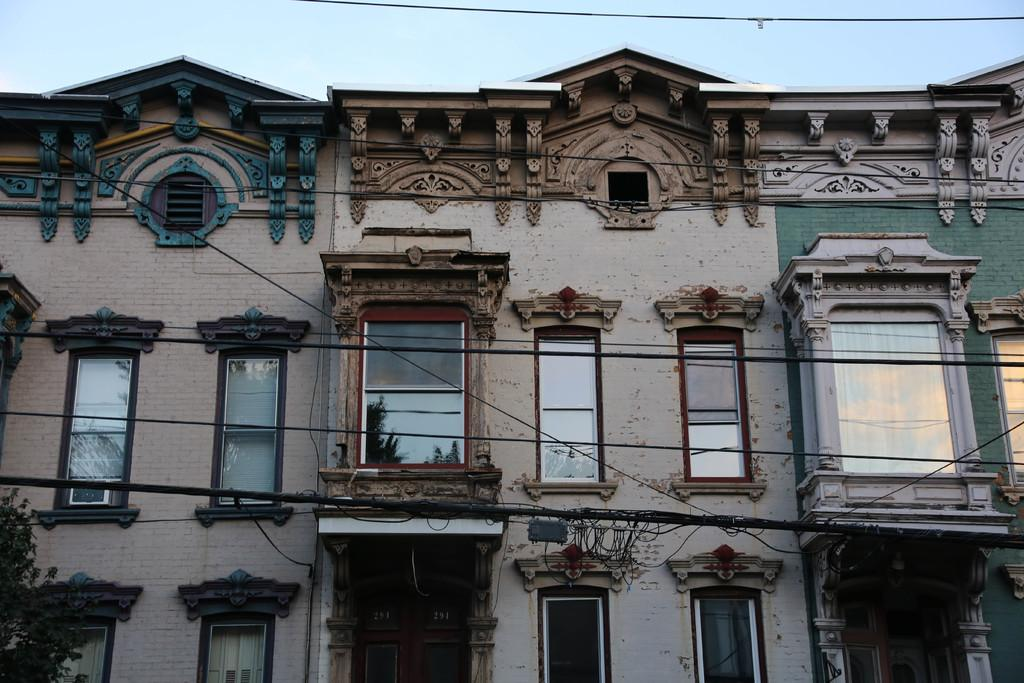What is located in the foreground of the picture? There are cables in the foreground of the picture. What can be seen in the center of the picture? There are buildings, windows, at least one door, and other objects in the center of the picture. Can you describe the buildings in the center of the picture? The buildings in the center of the picture have windows and at least one door. What other objects can be seen in the center of the picture? There are other objects in the center of the picture, but their specific details are not mentioned in the provided facts. What scientific theory is being discussed in the center of the picture? There is no indication in the image that a scientific theory is being discussed; the image primarily features buildings, windows, and doors. What type of attraction is present in the center of the picture? There is no attraction present in the center of the picture; the image primarily features buildings, windows, and doors. 